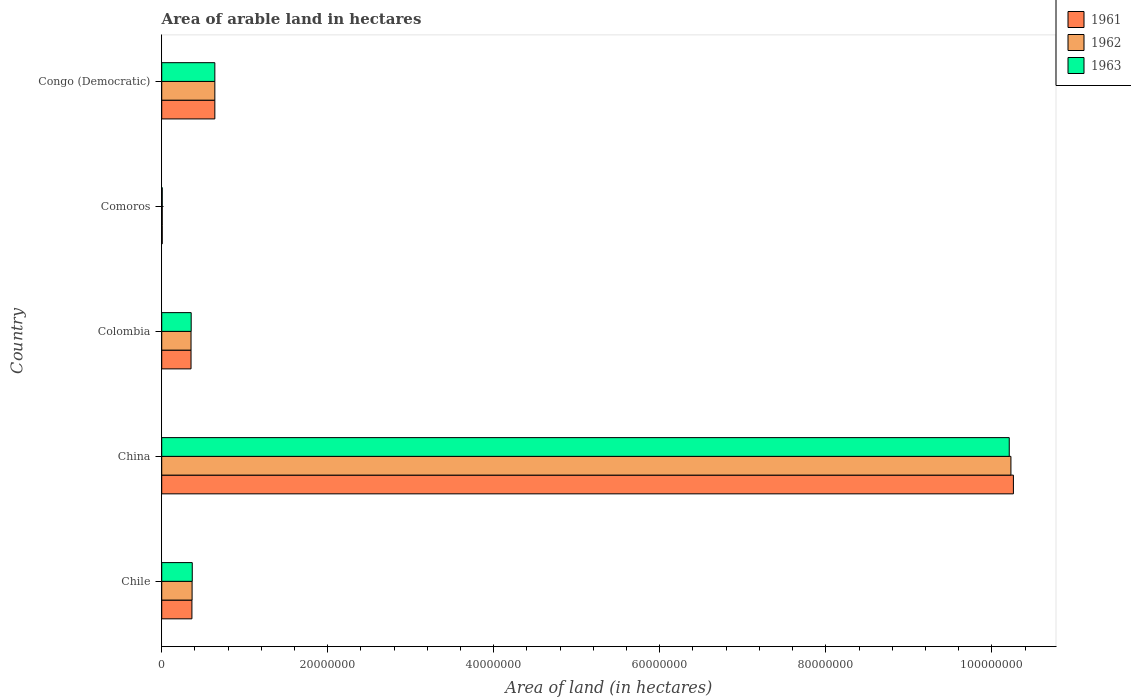How many different coloured bars are there?
Offer a very short reply. 3. How many groups of bars are there?
Your answer should be compact. 5. Are the number of bars per tick equal to the number of legend labels?
Offer a very short reply. Yes. Are the number of bars on each tick of the Y-axis equal?
Provide a short and direct response. Yes. How many bars are there on the 2nd tick from the top?
Your answer should be compact. 3. What is the label of the 4th group of bars from the top?
Provide a short and direct response. China. In how many cases, is the number of bars for a given country not equal to the number of legend labels?
Your answer should be very brief. 0. What is the total arable land in 1961 in Comoros?
Give a very brief answer. 6.50e+04. Across all countries, what is the maximum total arable land in 1961?
Provide a succinct answer. 1.03e+08. Across all countries, what is the minimum total arable land in 1963?
Make the answer very short. 6.50e+04. In which country was the total arable land in 1961 minimum?
Keep it short and to the point. Comoros. What is the total total arable land in 1963 in the graph?
Give a very brief answer. 1.16e+08. What is the difference between the total arable land in 1963 in China and that in Congo (Democratic)?
Make the answer very short. 9.57e+07. What is the difference between the total arable land in 1961 in Congo (Democratic) and the total arable land in 1963 in Colombia?
Provide a short and direct response. 2.85e+06. What is the average total arable land in 1962 per country?
Provide a succinct answer. 2.32e+07. What is the difference between the total arable land in 1962 and total arable land in 1963 in China?
Offer a very short reply. 2.00e+05. In how many countries, is the total arable land in 1962 greater than 92000000 hectares?
Offer a terse response. 1. What is the ratio of the total arable land in 1961 in China to that in Congo (Democratic)?
Keep it short and to the point. 16.03. Is the difference between the total arable land in 1962 in China and Congo (Democratic) greater than the difference between the total arable land in 1963 in China and Congo (Democratic)?
Provide a succinct answer. Yes. What is the difference between the highest and the second highest total arable land in 1961?
Give a very brief answer. 9.62e+07. What is the difference between the highest and the lowest total arable land in 1963?
Your answer should be very brief. 1.02e+08. What does the 3rd bar from the top in Congo (Democratic) represents?
Your answer should be very brief. 1961. What does the 1st bar from the bottom in Congo (Democratic) represents?
Provide a short and direct response. 1961. How many bars are there?
Your answer should be compact. 15. Are all the bars in the graph horizontal?
Offer a very short reply. Yes. How are the legend labels stacked?
Your answer should be very brief. Vertical. What is the title of the graph?
Your response must be concise. Area of arable land in hectares. Does "1975" appear as one of the legend labels in the graph?
Offer a terse response. No. What is the label or title of the X-axis?
Your answer should be compact. Area of land (in hectares). What is the label or title of the Y-axis?
Ensure brevity in your answer.  Country. What is the Area of land (in hectares) of 1961 in Chile?
Offer a terse response. 3.64e+06. What is the Area of land (in hectares) of 1962 in Chile?
Offer a terse response. 3.66e+06. What is the Area of land (in hectares) of 1963 in Chile?
Provide a short and direct response. 3.68e+06. What is the Area of land (in hectares) of 1961 in China?
Offer a very short reply. 1.03e+08. What is the Area of land (in hectares) in 1962 in China?
Keep it short and to the point. 1.02e+08. What is the Area of land (in hectares) in 1963 in China?
Provide a succinct answer. 1.02e+08. What is the Area of land (in hectares) in 1961 in Colombia?
Your answer should be very brief. 3.53e+06. What is the Area of land (in hectares) of 1962 in Colombia?
Provide a short and direct response. 3.53e+06. What is the Area of land (in hectares) in 1963 in Colombia?
Keep it short and to the point. 3.55e+06. What is the Area of land (in hectares) of 1961 in Comoros?
Give a very brief answer. 6.50e+04. What is the Area of land (in hectares) of 1962 in Comoros?
Provide a short and direct response. 6.50e+04. What is the Area of land (in hectares) in 1963 in Comoros?
Provide a succinct answer. 6.50e+04. What is the Area of land (in hectares) of 1961 in Congo (Democratic)?
Provide a short and direct response. 6.40e+06. What is the Area of land (in hectares) of 1962 in Congo (Democratic)?
Make the answer very short. 6.40e+06. What is the Area of land (in hectares) in 1963 in Congo (Democratic)?
Provide a short and direct response. 6.40e+06. Across all countries, what is the maximum Area of land (in hectares) of 1961?
Ensure brevity in your answer.  1.03e+08. Across all countries, what is the maximum Area of land (in hectares) in 1962?
Offer a terse response. 1.02e+08. Across all countries, what is the maximum Area of land (in hectares) in 1963?
Give a very brief answer. 1.02e+08. Across all countries, what is the minimum Area of land (in hectares) in 1961?
Provide a short and direct response. 6.50e+04. Across all countries, what is the minimum Area of land (in hectares) of 1962?
Make the answer very short. 6.50e+04. Across all countries, what is the minimum Area of land (in hectares) in 1963?
Keep it short and to the point. 6.50e+04. What is the total Area of land (in hectares) of 1961 in the graph?
Your answer should be very brief. 1.16e+08. What is the total Area of land (in hectares) in 1962 in the graph?
Offer a very short reply. 1.16e+08. What is the total Area of land (in hectares) of 1963 in the graph?
Give a very brief answer. 1.16e+08. What is the difference between the Area of land (in hectares) in 1961 in Chile and that in China?
Offer a very short reply. -9.90e+07. What is the difference between the Area of land (in hectares) in 1962 in Chile and that in China?
Provide a succinct answer. -9.86e+07. What is the difference between the Area of land (in hectares) of 1963 in Chile and that in China?
Offer a very short reply. -9.84e+07. What is the difference between the Area of land (in hectares) in 1961 in Chile and that in Colombia?
Make the answer very short. 1.08e+05. What is the difference between the Area of land (in hectares) of 1962 in Chile and that in Colombia?
Keep it short and to the point. 1.28e+05. What is the difference between the Area of land (in hectares) of 1963 in Chile and that in Colombia?
Provide a short and direct response. 1.30e+05. What is the difference between the Area of land (in hectares) in 1961 in Chile and that in Comoros?
Offer a terse response. 3.58e+06. What is the difference between the Area of land (in hectares) in 1962 in Chile and that in Comoros?
Make the answer very short. 3.60e+06. What is the difference between the Area of land (in hectares) in 1963 in Chile and that in Comoros?
Ensure brevity in your answer.  3.62e+06. What is the difference between the Area of land (in hectares) in 1961 in Chile and that in Congo (Democratic)?
Ensure brevity in your answer.  -2.76e+06. What is the difference between the Area of land (in hectares) in 1962 in Chile and that in Congo (Democratic)?
Offer a very short reply. -2.74e+06. What is the difference between the Area of land (in hectares) of 1963 in Chile and that in Congo (Democratic)?
Offer a very short reply. -2.72e+06. What is the difference between the Area of land (in hectares) in 1961 in China and that in Colombia?
Your answer should be compact. 9.91e+07. What is the difference between the Area of land (in hectares) of 1962 in China and that in Colombia?
Ensure brevity in your answer.  9.88e+07. What is the difference between the Area of land (in hectares) in 1963 in China and that in Colombia?
Your answer should be very brief. 9.86e+07. What is the difference between the Area of land (in hectares) in 1961 in China and that in Comoros?
Offer a terse response. 1.03e+08. What is the difference between the Area of land (in hectares) in 1962 in China and that in Comoros?
Give a very brief answer. 1.02e+08. What is the difference between the Area of land (in hectares) in 1963 in China and that in Comoros?
Offer a terse response. 1.02e+08. What is the difference between the Area of land (in hectares) of 1961 in China and that in Congo (Democratic)?
Keep it short and to the point. 9.62e+07. What is the difference between the Area of land (in hectares) in 1962 in China and that in Congo (Democratic)?
Your answer should be very brief. 9.59e+07. What is the difference between the Area of land (in hectares) of 1963 in China and that in Congo (Democratic)?
Offer a very short reply. 9.57e+07. What is the difference between the Area of land (in hectares) in 1961 in Colombia and that in Comoros?
Ensure brevity in your answer.  3.47e+06. What is the difference between the Area of land (in hectares) of 1962 in Colombia and that in Comoros?
Keep it short and to the point. 3.47e+06. What is the difference between the Area of land (in hectares) in 1963 in Colombia and that in Comoros?
Your answer should be compact. 3.48e+06. What is the difference between the Area of land (in hectares) of 1961 in Colombia and that in Congo (Democratic)?
Ensure brevity in your answer.  -2.87e+06. What is the difference between the Area of land (in hectares) in 1962 in Colombia and that in Congo (Democratic)?
Provide a succinct answer. -2.87e+06. What is the difference between the Area of land (in hectares) in 1963 in Colombia and that in Congo (Democratic)?
Offer a very short reply. -2.85e+06. What is the difference between the Area of land (in hectares) of 1961 in Comoros and that in Congo (Democratic)?
Your response must be concise. -6.34e+06. What is the difference between the Area of land (in hectares) in 1962 in Comoros and that in Congo (Democratic)?
Offer a terse response. -6.34e+06. What is the difference between the Area of land (in hectares) in 1963 in Comoros and that in Congo (Democratic)?
Provide a short and direct response. -6.34e+06. What is the difference between the Area of land (in hectares) of 1961 in Chile and the Area of land (in hectares) of 1962 in China?
Give a very brief answer. -9.87e+07. What is the difference between the Area of land (in hectares) of 1961 in Chile and the Area of land (in hectares) of 1963 in China?
Give a very brief answer. -9.85e+07. What is the difference between the Area of land (in hectares) in 1962 in Chile and the Area of land (in hectares) in 1963 in China?
Make the answer very short. -9.84e+07. What is the difference between the Area of land (in hectares) in 1961 in Chile and the Area of land (in hectares) in 1962 in Colombia?
Your answer should be compact. 1.08e+05. What is the difference between the Area of land (in hectares) in 1961 in Chile and the Area of land (in hectares) in 1963 in Colombia?
Provide a short and direct response. 9.00e+04. What is the difference between the Area of land (in hectares) in 1961 in Chile and the Area of land (in hectares) in 1962 in Comoros?
Give a very brief answer. 3.58e+06. What is the difference between the Area of land (in hectares) in 1961 in Chile and the Area of land (in hectares) in 1963 in Comoros?
Your response must be concise. 3.58e+06. What is the difference between the Area of land (in hectares) in 1962 in Chile and the Area of land (in hectares) in 1963 in Comoros?
Provide a short and direct response. 3.60e+06. What is the difference between the Area of land (in hectares) of 1961 in Chile and the Area of land (in hectares) of 1962 in Congo (Democratic)?
Your answer should be very brief. -2.76e+06. What is the difference between the Area of land (in hectares) of 1961 in Chile and the Area of land (in hectares) of 1963 in Congo (Democratic)?
Your answer should be very brief. -2.76e+06. What is the difference between the Area of land (in hectares) of 1962 in Chile and the Area of land (in hectares) of 1963 in Congo (Democratic)?
Ensure brevity in your answer.  -2.74e+06. What is the difference between the Area of land (in hectares) of 1961 in China and the Area of land (in hectares) of 1962 in Colombia?
Give a very brief answer. 9.91e+07. What is the difference between the Area of land (in hectares) of 1961 in China and the Area of land (in hectares) of 1963 in Colombia?
Make the answer very short. 9.90e+07. What is the difference between the Area of land (in hectares) of 1962 in China and the Area of land (in hectares) of 1963 in Colombia?
Provide a succinct answer. 9.88e+07. What is the difference between the Area of land (in hectares) in 1961 in China and the Area of land (in hectares) in 1962 in Comoros?
Keep it short and to the point. 1.03e+08. What is the difference between the Area of land (in hectares) of 1961 in China and the Area of land (in hectares) of 1963 in Comoros?
Provide a succinct answer. 1.03e+08. What is the difference between the Area of land (in hectares) in 1962 in China and the Area of land (in hectares) in 1963 in Comoros?
Your response must be concise. 1.02e+08. What is the difference between the Area of land (in hectares) of 1961 in China and the Area of land (in hectares) of 1962 in Congo (Democratic)?
Provide a succinct answer. 9.62e+07. What is the difference between the Area of land (in hectares) of 1961 in China and the Area of land (in hectares) of 1963 in Congo (Democratic)?
Give a very brief answer. 9.62e+07. What is the difference between the Area of land (in hectares) of 1962 in China and the Area of land (in hectares) of 1963 in Congo (Democratic)?
Give a very brief answer. 9.59e+07. What is the difference between the Area of land (in hectares) of 1961 in Colombia and the Area of land (in hectares) of 1962 in Comoros?
Provide a succinct answer. 3.47e+06. What is the difference between the Area of land (in hectares) in 1961 in Colombia and the Area of land (in hectares) in 1963 in Comoros?
Ensure brevity in your answer.  3.47e+06. What is the difference between the Area of land (in hectares) of 1962 in Colombia and the Area of land (in hectares) of 1963 in Comoros?
Your response must be concise. 3.47e+06. What is the difference between the Area of land (in hectares) of 1961 in Colombia and the Area of land (in hectares) of 1962 in Congo (Democratic)?
Provide a short and direct response. -2.87e+06. What is the difference between the Area of land (in hectares) of 1961 in Colombia and the Area of land (in hectares) of 1963 in Congo (Democratic)?
Give a very brief answer. -2.87e+06. What is the difference between the Area of land (in hectares) in 1962 in Colombia and the Area of land (in hectares) in 1963 in Congo (Democratic)?
Provide a succinct answer. -2.87e+06. What is the difference between the Area of land (in hectares) of 1961 in Comoros and the Area of land (in hectares) of 1962 in Congo (Democratic)?
Keep it short and to the point. -6.34e+06. What is the difference between the Area of land (in hectares) of 1961 in Comoros and the Area of land (in hectares) of 1963 in Congo (Democratic)?
Give a very brief answer. -6.34e+06. What is the difference between the Area of land (in hectares) in 1962 in Comoros and the Area of land (in hectares) in 1963 in Congo (Democratic)?
Keep it short and to the point. -6.34e+06. What is the average Area of land (in hectares) of 1961 per country?
Provide a succinct answer. 2.32e+07. What is the average Area of land (in hectares) of 1962 per country?
Provide a short and direct response. 2.32e+07. What is the average Area of land (in hectares) of 1963 per country?
Provide a succinct answer. 2.32e+07. What is the difference between the Area of land (in hectares) in 1961 and Area of land (in hectares) in 1963 in China?
Your answer should be compact. 5.00e+05. What is the difference between the Area of land (in hectares) in 1961 and Area of land (in hectares) in 1962 in Colombia?
Your answer should be very brief. 0. What is the difference between the Area of land (in hectares) of 1961 and Area of land (in hectares) of 1963 in Colombia?
Keep it short and to the point. -1.80e+04. What is the difference between the Area of land (in hectares) of 1962 and Area of land (in hectares) of 1963 in Colombia?
Provide a short and direct response. -1.80e+04. What is the difference between the Area of land (in hectares) of 1961 and Area of land (in hectares) of 1963 in Congo (Democratic)?
Keep it short and to the point. 0. What is the difference between the Area of land (in hectares) in 1962 and Area of land (in hectares) in 1963 in Congo (Democratic)?
Provide a short and direct response. 0. What is the ratio of the Area of land (in hectares) in 1961 in Chile to that in China?
Keep it short and to the point. 0.04. What is the ratio of the Area of land (in hectares) in 1962 in Chile to that in China?
Ensure brevity in your answer.  0.04. What is the ratio of the Area of land (in hectares) of 1963 in Chile to that in China?
Provide a short and direct response. 0.04. What is the ratio of the Area of land (in hectares) in 1961 in Chile to that in Colombia?
Your response must be concise. 1.03. What is the ratio of the Area of land (in hectares) in 1962 in Chile to that in Colombia?
Offer a very short reply. 1.04. What is the ratio of the Area of land (in hectares) of 1963 in Chile to that in Colombia?
Make the answer very short. 1.04. What is the ratio of the Area of land (in hectares) of 1962 in Chile to that in Comoros?
Make the answer very short. 56.31. What is the ratio of the Area of land (in hectares) in 1963 in Chile to that in Comoros?
Keep it short and to the point. 56.62. What is the ratio of the Area of land (in hectares) in 1961 in Chile to that in Congo (Democratic)?
Keep it short and to the point. 0.57. What is the ratio of the Area of land (in hectares) of 1962 in Chile to that in Congo (Democratic)?
Provide a short and direct response. 0.57. What is the ratio of the Area of land (in hectares) of 1963 in Chile to that in Congo (Democratic)?
Offer a very short reply. 0.57. What is the ratio of the Area of land (in hectares) in 1961 in China to that in Colombia?
Ensure brevity in your answer.  29.05. What is the ratio of the Area of land (in hectares) of 1962 in China to that in Colombia?
Give a very brief answer. 28.96. What is the ratio of the Area of land (in hectares) in 1963 in China to that in Colombia?
Your response must be concise. 28.76. What is the ratio of the Area of land (in hectares) of 1961 in China to that in Comoros?
Make the answer very short. 1578.46. What is the ratio of the Area of land (in hectares) in 1962 in China to that in Comoros?
Your answer should be compact. 1573.85. What is the ratio of the Area of land (in hectares) in 1963 in China to that in Comoros?
Provide a short and direct response. 1570.77. What is the ratio of the Area of land (in hectares) of 1961 in China to that in Congo (Democratic)?
Offer a terse response. 16.03. What is the ratio of the Area of land (in hectares) of 1962 in China to that in Congo (Democratic)?
Your answer should be compact. 15.98. What is the ratio of the Area of land (in hectares) of 1963 in China to that in Congo (Democratic)?
Give a very brief answer. 15.95. What is the ratio of the Area of land (in hectares) in 1961 in Colombia to that in Comoros?
Make the answer very short. 54.34. What is the ratio of the Area of land (in hectares) of 1962 in Colombia to that in Comoros?
Your answer should be very brief. 54.34. What is the ratio of the Area of land (in hectares) in 1963 in Colombia to that in Comoros?
Make the answer very short. 54.62. What is the ratio of the Area of land (in hectares) of 1961 in Colombia to that in Congo (Democratic)?
Your answer should be very brief. 0.55. What is the ratio of the Area of land (in hectares) in 1962 in Colombia to that in Congo (Democratic)?
Your answer should be compact. 0.55. What is the ratio of the Area of land (in hectares) in 1963 in Colombia to that in Congo (Democratic)?
Make the answer very short. 0.55. What is the ratio of the Area of land (in hectares) of 1961 in Comoros to that in Congo (Democratic)?
Your answer should be very brief. 0.01. What is the ratio of the Area of land (in hectares) of 1962 in Comoros to that in Congo (Democratic)?
Ensure brevity in your answer.  0.01. What is the ratio of the Area of land (in hectares) of 1963 in Comoros to that in Congo (Democratic)?
Provide a short and direct response. 0.01. What is the difference between the highest and the second highest Area of land (in hectares) in 1961?
Give a very brief answer. 9.62e+07. What is the difference between the highest and the second highest Area of land (in hectares) of 1962?
Offer a very short reply. 9.59e+07. What is the difference between the highest and the second highest Area of land (in hectares) of 1963?
Offer a terse response. 9.57e+07. What is the difference between the highest and the lowest Area of land (in hectares) of 1961?
Provide a succinct answer. 1.03e+08. What is the difference between the highest and the lowest Area of land (in hectares) of 1962?
Make the answer very short. 1.02e+08. What is the difference between the highest and the lowest Area of land (in hectares) of 1963?
Keep it short and to the point. 1.02e+08. 